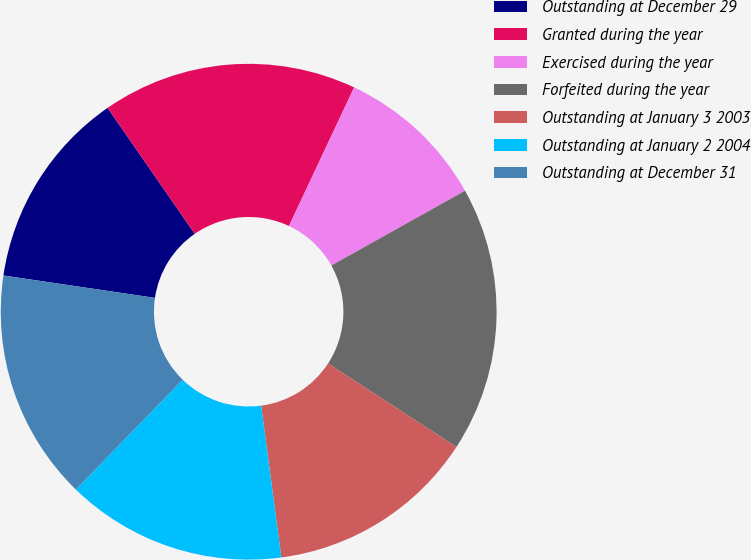<chart> <loc_0><loc_0><loc_500><loc_500><pie_chart><fcel>Outstanding at December 29<fcel>Granted during the year<fcel>Exercised during the year<fcel>Forfeited during the year<fcel>Outstanding at January 3 2003<fcel>Outstanding at January 2 2004<fcel>Outstanding at December 31<nl><fcel>13.03%<fcel>16.63%<fcel>9.89%<fcel>17.3%<fcel>13.71%<fcel>14.38%<fcel>15.06%<nl></chart> 